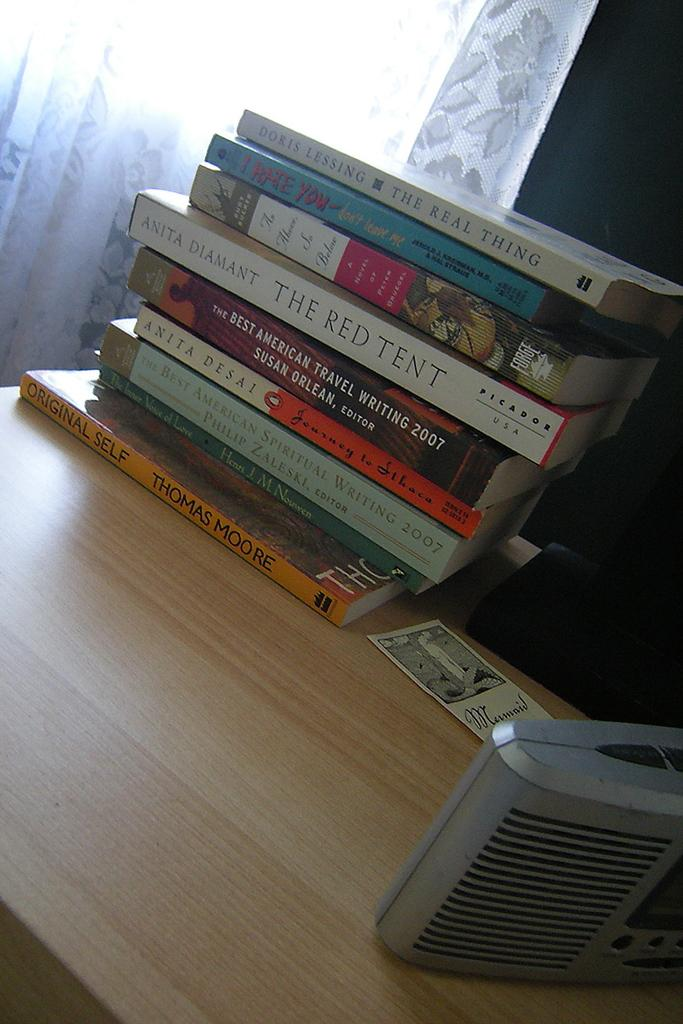<image>
Offer a succinct explanation of the picture presented. Several books including, "The Red Tent" are stacked in a pile on a wooden desk. 